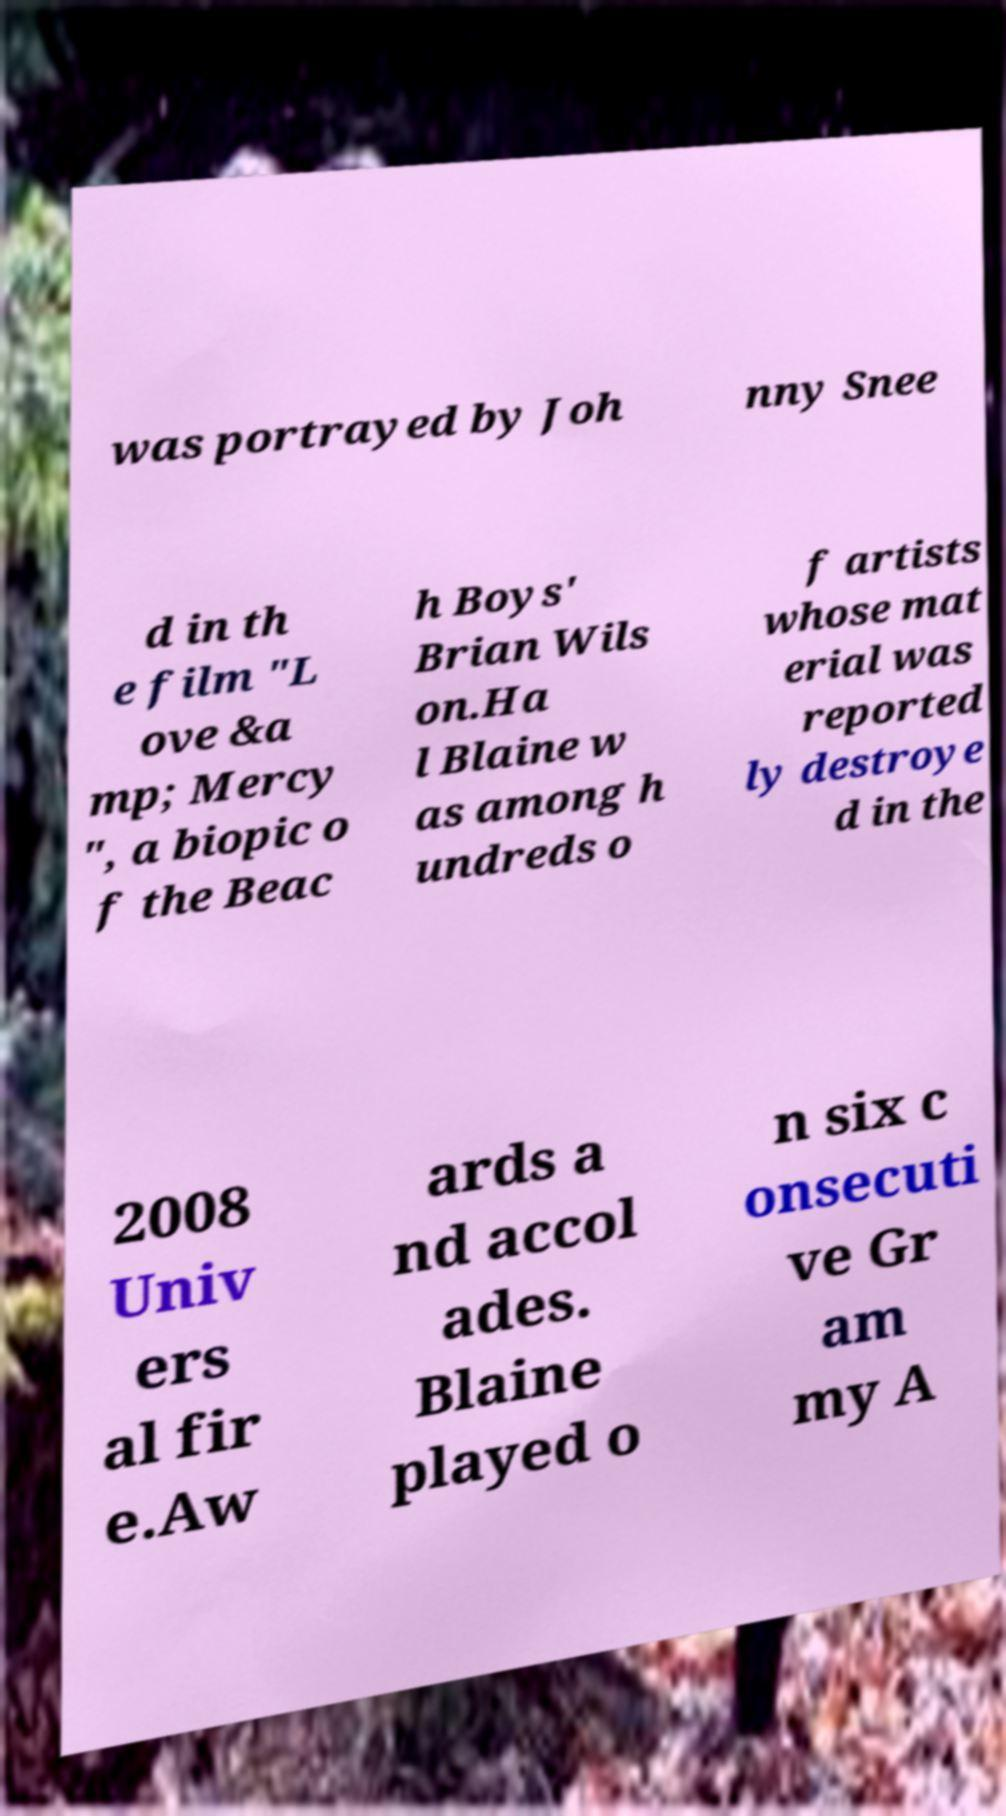Can you read and provide the text displayed in the image?This photo seems to have some interesting text. Can you extract and type it out for me? was portrayed by Joh nny Snee d in th e film "L ove &a mp; Mercy ", a biopic o f the Beac h Boys' Brian Wils on.Ha l Blaine w as among h undreds o f artists whose mat erial was reported ly destroye d in the 2008 Univ ers al fir e.Aw ards a nd accol ades. Blaine played o n six c onsecuti ve Gr am my A 